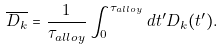Convert formula to latex. <formula><loc_0><loc_0><loc_500><loc_500>\overline { D _ { k } } = \frac { 1 } { \tau _ { a l l o y } } \int _ { 0 } ^ { \tau _ { a l l o y } } d t ^ { \prime } D _ { k } ( t ^ { \prime } ) .</formula> 